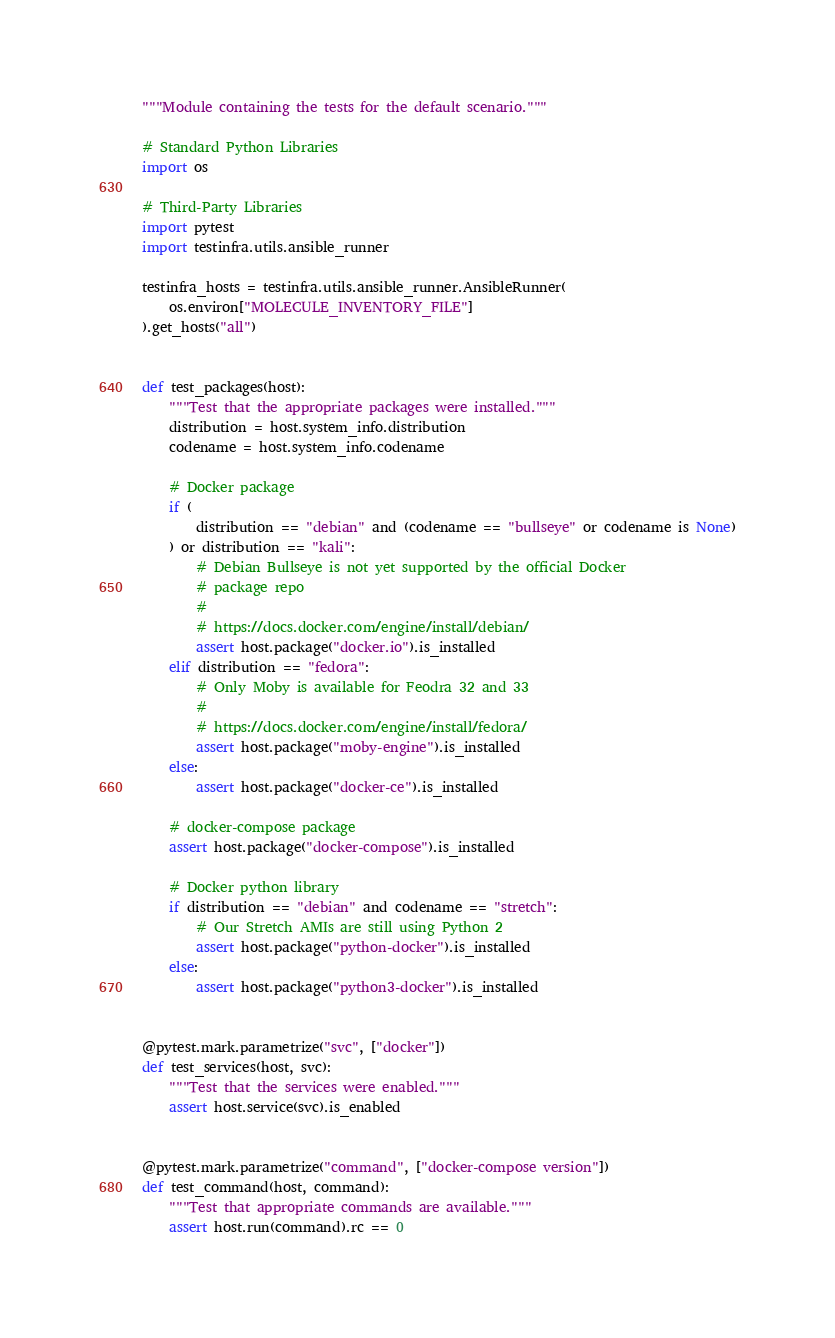<code> <loc_0><loc_0><loc_500><loc_500><_Python_>"""Module containing the tests for the default scenario."""

# Standard Python Libraries
import os

# Third-Party Libraries
import pytest
import testinfra.utils.ansible_runner

testinfra_hosts = testinfra.utils.ansible_runner.AnsibleRunner(
    os.environ["MOLECULE_INVENTORY_FILE"]
).get_hosts("all")


def test_packages(host):
    """Test that the appropriate packages were installed."""
    distribution = host.system_info.distribution
    codename = host.system_info.codename

    # Docker package
    if (
        distribution == "debian" and (codename == "bullseye" or codename is None)
    ) or distribution == "kali":
        # Debian Bullseye is not yet supported by the official Docker
        # package repo
        #
        # https://docs.docker.com/engine/install/debian/
        assert host.package("docker.io").is_installed
    elif distribution == "fedora":
        # Only Moby is available for Feodra 32 and 33
        #
        # https://docs.docker.com/engine/install/fedora/
        assert host.package("moby-engine").is_installed
    else:
        assert host.package("docker-ce").is_installed

    # docker-compose package
    assert host.package("docker-compose").is_installed

    # Docker python library
    if distribution == "debian" and codename == "stretch":
        # Our Stretch AMIs are still using Python 2
        assert host.package("python-docker").is_installed
    else:
        assert host.package("python3-docker").is_installed


@pytest.mark.parametrize("svc", ["docker"])
def test_services(host, svc):
    """Test that the services were enabled."""
    assert host.service(svc).is_enabled


@pytest.mark.parametrize("command", ["docker-compose version"])
def test_command(host, command):
    """Test that appropriate commands are available."""
    assert host.run(command).rc == 0
</code> 